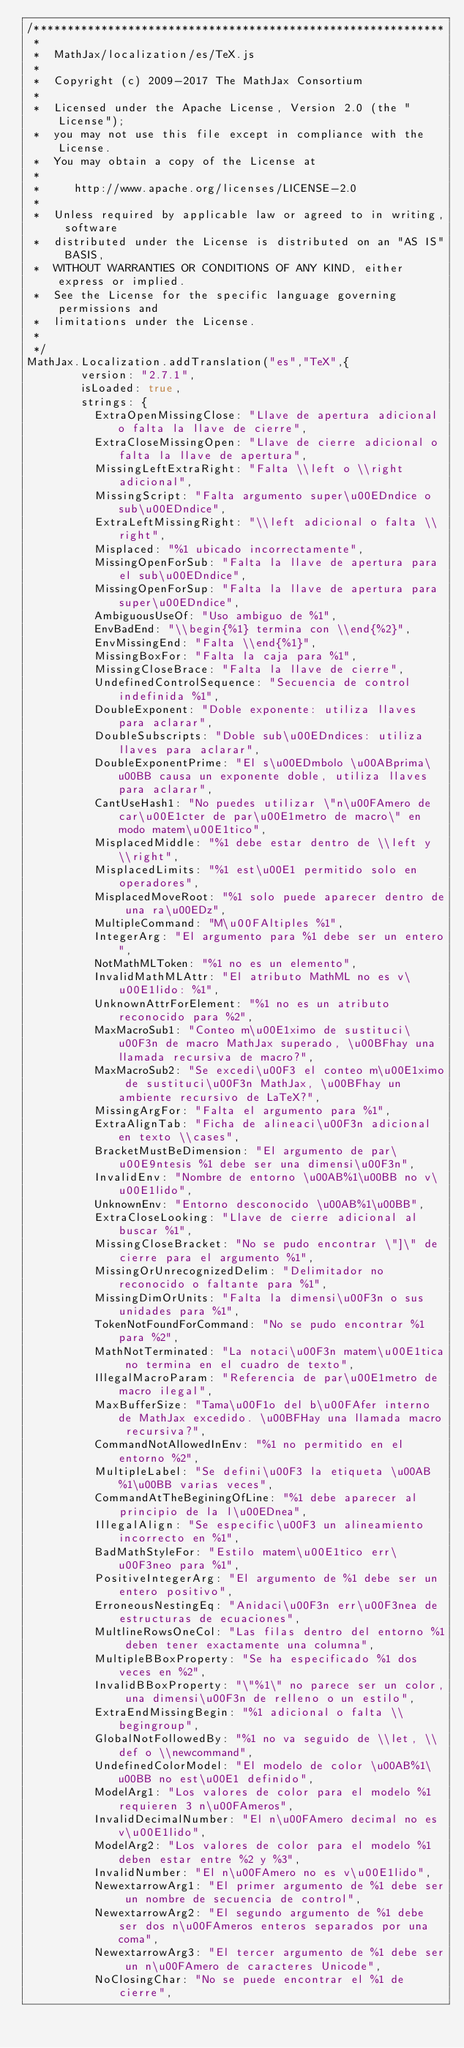Convert code to text. <code><loc_0><loc_0><loc_500><loc_500><_JavaScript_>/*************************************************************
 *
 *  MathJax/localization/es/TeX.js
 *
 *  Copyright (c) 2009-2017 The MathJax Consortium
 *
 *  Licensed under the Apache License, Version 2.0 (the "License");
 *  you may not use this file except in compliance with the License.
 *  You may obtain a copy of the License at
 *
 *     http://www.apache.org/licenses/LICENSE-2.0
 *
 *  Unless required by applicable law or agreed to in writing, software
 *  distributed under the License is distributed on an "AS IS" BASIS,
 *  WITHOUT WARRANTIES OR CONDITIONS OF ANY KIND, either express or implied.
 *  See the License for the specific language governing permissions and
 *  limitations under the License.
 *
 */
MathJax.Localization.addTranslation("es","TeX",{
        version: "2.7.1",
        isLoaded: true,
        strings: {
          ExtraOpenMissingClose: "Llave de apertura adicional o falta la llave de cierre",
          ExtraCloseMissingOpen: "Llave de cierre adicional o falta la llave de apertura",
          MissingLeftExtraRight: "Falta \\left o \\right adicional",
          MissingScript: "Falta argumento super\u00EDndice o sub\u00EDndice",
          ExtraLeftMissingRight: "\\left adicional o falta \\right",
          Misplaced: "%1 ubicado incorrectamente",
          MissingOpenForSub: "Falta la llave de apertura para el sub\u00EDndice",
          MissingOpenForSup: "Falta la llave de apertura para super\u00EDndice",
          AmbiguousUseOf: "Uso ambiguo de %1",
          EnvBadEnd: "\\begin{%1} termina con \\end{%2}",
          EnvMissingEnd: "Falta \\end{%1}",
          MissingBoxFor: "Falta la caja para %1",
          MissingCloseBrace: "Falta la llave de cierre",
          UndefinedControlSequence: "Secuencia de control indefinida %1",
          DoubleExponent: "Doble exponente: utiliza llaves para aclarar",
          DoubleSubscripts: "Doble sub\u00EDndices: utiliza llaves para aclarar",
          DoubleExponentPrime: "El s\u00EDmbolo \u00ABprima\u00BB causa un exponente doble, utiliza llaves para aclarar",
          CantUseHash1: "No puedes utilizar \"n\u00FAmero de car\u00E1cter de par\u00E1metro de macro\" en modo matem\u00E1tico",
          MisplacedMiddle: "%1 debe estar dentro de \\left y \\right",
          MisplacedLimits: "%1 est\u00E1 permitido solo en operadores",
          MisplacedMoveRoot: "%1 solo puede aparecer dentro de una ra\u00EDz",
          MultipleCommand: "M\u00FAltiples %1",
          IntegerArg: "El argumento para %1 debe ser un entero",
          NotMathMLToken: "%1 no es un elemento",
          InvalidMathMLAttr: "El atributo MathML no es v\u00E1lido: %1",
          UnknownAttrForElement: "%1 no es un atributo reconocido para %2",
          MaxMacroSub1: "Conteo m\u00E1ximo de sustituci\u00F3n de macro MathJax superado, \u00BFhay una llamada recursiva de macro?",
          MaxMacroSub2: "Se excedi\u00F3 el conteo m\u00E1ximo de sustituci\u00F3n MathJax, \u00BFhay un ambiente recursivo de LaTeX?",
          MissingArgFor: "Falta el argumento para %1",
          ExtraAlignTab: "Ficha de alineaci\u00F3n adicional en texto \\cases",
          BracketMustBeDimension: "El argumento de par\u00E9ntesis %1 debe ser una dimensi\u00F3n",
          InvalidEnv: "Nombre de entorno \u00AB%1\u00BB no v\u00E1lido",
          UnknownEnv: "Entorno desconocido \u00AB%1\u00BB",
          ExtraCloseLooking: "Llave de cierre adicional al buscar %1",
          MissingCloseBracket: "No se pudo encontrar \"]\" de cierre para el argumento %1",
          MissingOrUnrecognizedDelim: "Delimitador no reconocido o faltante para %1",
          MissingDimOrUnits: "Falta la dimensi\u00F3n o sus unidades para %1",
          TokenNotFoundForCommand: "No se pudo encontrar %1 para %2",
          MathNotTerminated: "La notaci\u00F3n matem\u00E1tica no termina en el cuadro de texto",
          IllegalMacroParam: "Referencia de par\u00E1metro de macro ilegal",
          MaxBufferSize: "Tama\u00F1o del b\u00FAfer interno de MathJax excedido. \u00BFHay una llamada macro recursiva?",
          CommandNotAllowedInEnv: "%1 no permitido en el entorno %2",
          MultipleLabel: "Se defini\u00F3 la etiqueta \u00AB%1\u00BB varias veces",
          CommandAtTheBeginingOfLine: "%1 debe aparecer al principio de la l\u00EDnea",
          IllegalAlign: "Se especific\u00F3 un alineamiento incorrecto en %1",
          BadMathStyleFor: "Estilo matem\u00E1tico err\u00F3neo para %1",
          PositiveIntegerArg: "El argumento de %1 debe ser un entero positivo",
          ErroneousNestingEq: "Anidaci\u00F3n err\u00F3nea de estructuras de ecuaciones",
          MultlineRowsOneCol: "Las filas dentro del entorno %1 deben tener exactamente una columna",
          MultipleBBoxProperty: "Se ha especificado %1 dos veces en %2",
          InvalidBBoxProperty: "\"%1\" no parece ser un color, una dimensi\u00F3n de relleno o un estilo",
          ExtraEndMissingBegin: "%1 adicional o falta \\begingroup",
          GlobalNotFollowedBy: "%1 no va seguido de \\let, \\def o \\newcommand",
          UndefinedColorModel: "El modelo de color \u00AB%1\u00BB no est\u00E1 definido",
          ModelArg1: "Los valores de color para el modelo %1 requieren 3 n\u00FAmeros",
          InvalidDecimalNumber: "El n\u00FAmero decimal no es v\u00E1lido",
          ModelArg2: "Los valores de color para el modelo %1 deben estar entre %2 y %3",
          InvalidNumber: "El n\u00FAmero no es v\u00E1lido",
          NewextarrowArg1: "El primer argumento de %1 debe ser un nombre de secuencia de control",
          NewextarrowArg2: "El segundo argumento de %1 debe ser dos n\u00FAmeros enteros separados por una coma",
          NewextarrowArg3: "El tercer argumento de %1 debe ser un n\u00FAmero de caracteres Unicode",
          NoClosingChar: "No se puede encontrar el %1 de cierre",</code> 